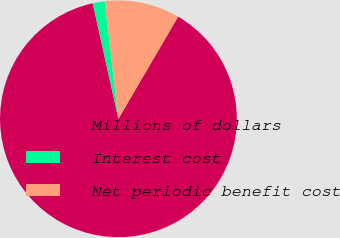<chart> <loc_0><loc_0><loc_500><loc_500><pie_chart><fcel>Millions of dollars<fcel>Interest cost<fcel>Net periodic benefit cost<nl><fcel>88.1%<fcel>1.63%<fcel>10.27%<nl></chart> 